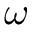Convert formula to latex. <formula><loc_0><loc_0><loc_500><loc_500>\omega</formula> 